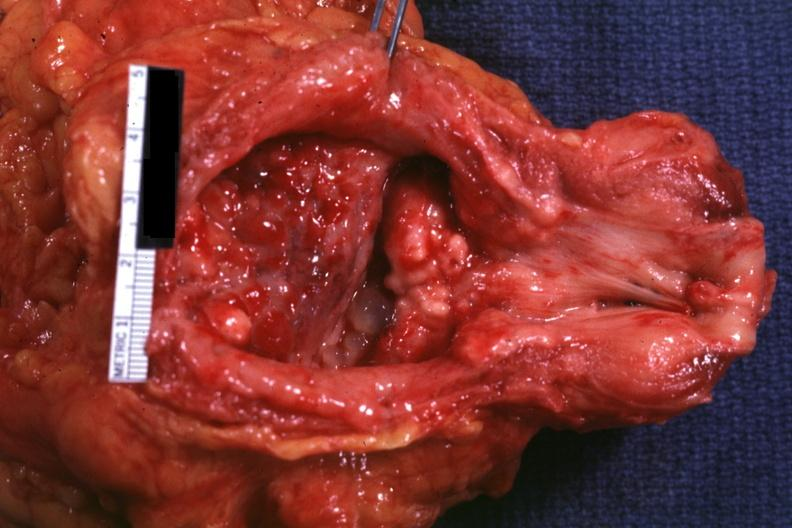s prostate present?
Answer the question using a single word or phrase. Yes 